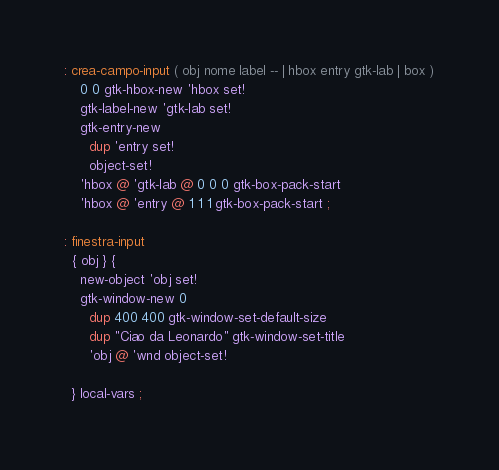<code> <loc_0><loc_0><loc_500><loc_500><_Forth_>: crea-campo-input ( obj nome label -- | hbox entry gtk-lab | box )
    0 0 gtk-hbox-new 'hbox set!
    gtk-label-new 'gtk-lab set!
    gtk-entry-new 
      dup 'entry set!
      object-set!
    'hbox @ 'gtk-lab @ 0 0 0 gtk-box-pack-start
    'hbox @ 'entry @ 1 1 1 gtk-box-pack-start ;

: finestra-input
  { obj } {
    new-object 'obj set!
    gtk-window-new 0
      dup 400 400 gtk-window-set-default-size      
      dup "Ciao da Leonardo" gtk-window-set-title
      'obj @ 'wnd object-set!

  } local-vars ;

</code> 